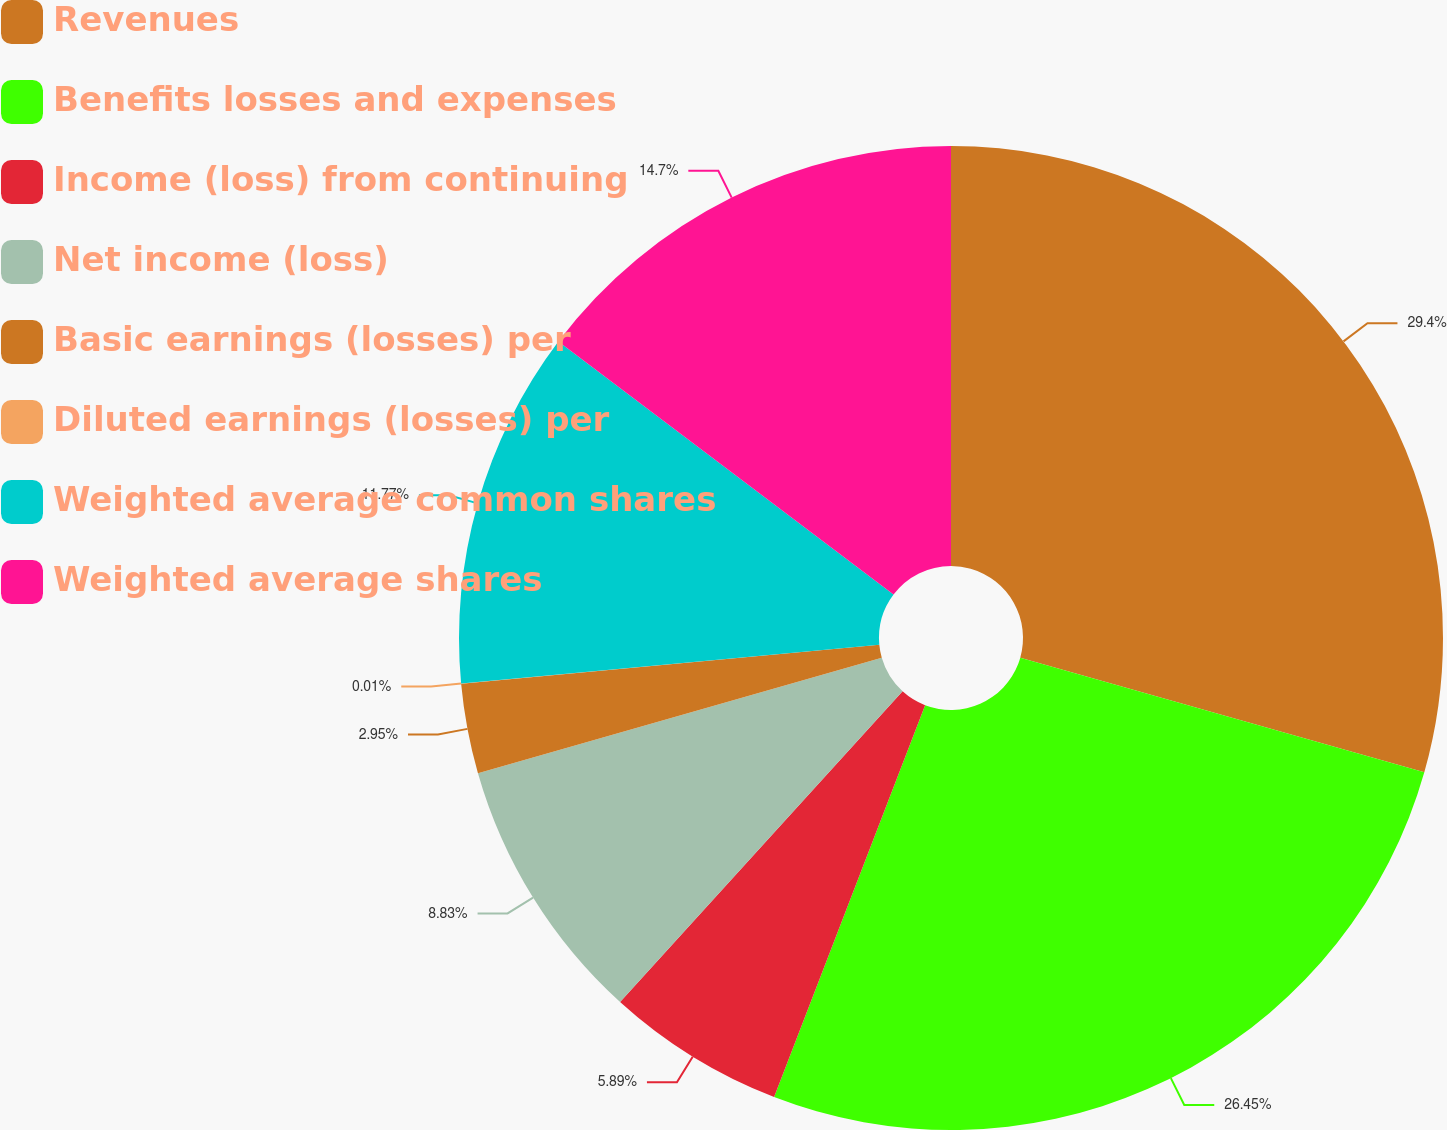<chart> <loc_0><loc_0><loc_500><loc_500><pie_chart><fcel>Revenues<fcel>Benefits losses and expenses<fcel>Income (loss) from continuing<fcel>Net income (loss)<fcel>Basic earnings (losses) per<fcel>Diluted earnings (losses) per<fcel>Weighted average common shares<fcel>Weighted average shares<nl><fcel>29.41%<fcel>26.46%<fcel>5.89%<fcel>8.83%<fcel>2.95%<fcel>0.01%<fcel>11.77%<fcel>14.71%<nl></chart> 